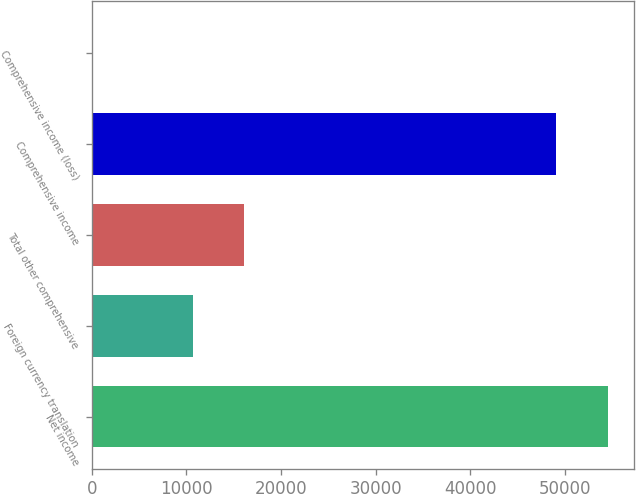<chart> <loc_0><loc_0><loc_500><loc_500><bar_chart><fcel>Net income<fcel>Foreign currency translation<fcel>Total other comprehensive<fcel>Comprehensive income<fcel>Comprehensive income (loss)<nl><fcel>54527<fcel>10662<fcel>16094<fcel>49095<fcel>32<nl></chart> 